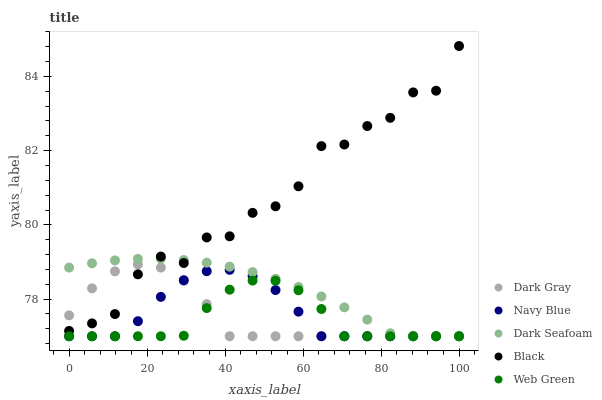Does Web Green have the minimum area under the curve?
Answer yes or no. Yes. Does Black have the maximum area under the curve?
Answer yes or no. Yes. Does Navy Blue have the minimum area under the curve?
Answer yes or no. No. Does Navy Blue have the maximum area under the curve?
Answer yes or no. No. Is Dark Seafoam the smoothest?
Answer yes or no. Yes. Is Black the roughest?
Answer yes or no. Yes. Is Navy Blue the smoothest?
Answer yes or no. No. Is Navy Blue the roughest?
Answer yes or no. No. Does Dark Gray have the lowest value?
Answer yes or no. Yes. Does Black have the lowest value?
Answer yes or no. No. Does Black have the highest value?
Answer yes or no. Yes. Does Navy Blue have the highest value?
Answer yes or no. No. Is Web Green less than Black?
Answer yes or no. Yes. Is Black greater than Web Green?
Answer yes or no. Yes. Does Web Green intersect Dark Gray?
Answer yes or no. Yes. Is Web Green less than Dark Gray?
Answer yes or no. No. Is Web Green greater than Dark Gray?
Answer yes or no. No. Does Web Green intersect Black?
Answer yes or no. No. 